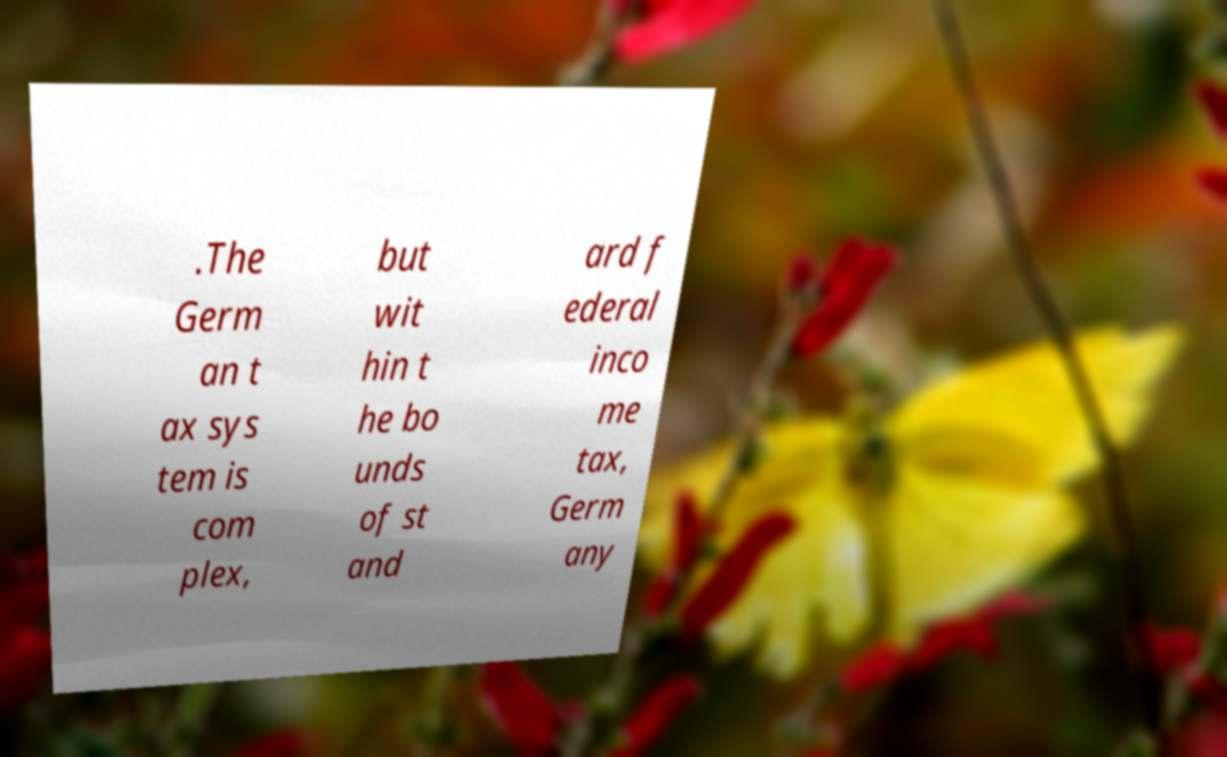What messages or text are displayed in this image? I need them in a readable, typed format. .The Germ an t ax sys tem is com plex, but wit hin t he bo unds of st and ard f ederal inco me tax, Germ any 